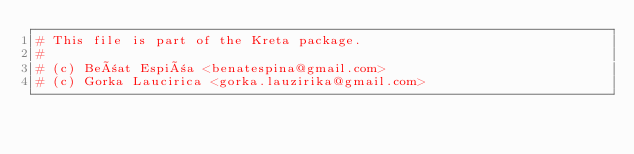<code> <loc_0><loc_0><loc_500><loc_500><_YAML_># This file is part of the Kreta package.
#
# (c) Beñat Espiña <benatespina@gmail.com>
# (c) Gorka Laucirica <gorka.lauzirika@gmail.com></code> 